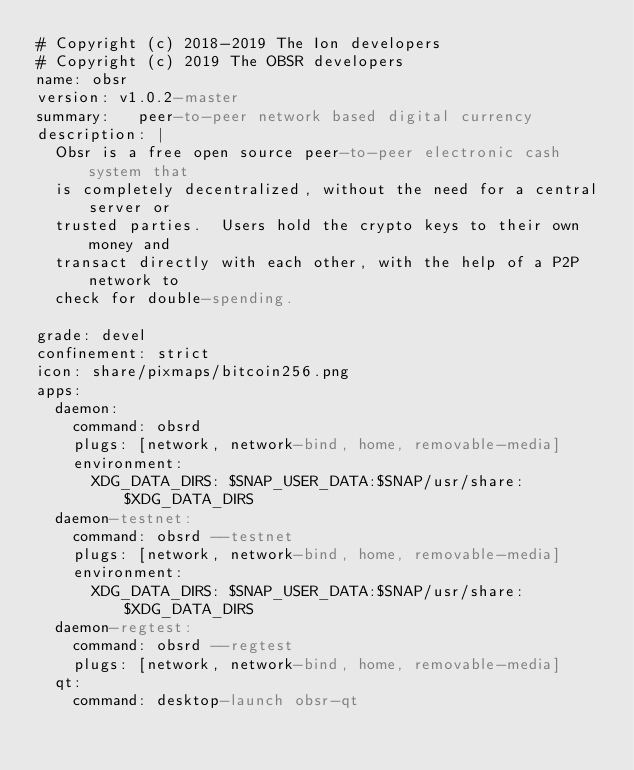<code> <loc_0><loc_0><loc_500><loc_500><_YAML_># Copyright (c) 2018-2019 The Ion developers
# Copyright (c) 2019 The OBSR developers
name: obsr
version: v1.0.2-master
summary:   peer-to-peer network based digital currency
description: |
  Obsr is a free open source peer-to-peer electronic cash system that
  is completely decentralized, without the need for a central server or
  trusted parties.  Users hold the crypto keys to their own money and
  transact directly with each other, with the help of a P2P network to
  check for double-spending.

grade: devel
confinement: strict
icon: share/pixmaps/bitcoin256.png
apps:
  daemon:
    command: obsrd
    plugs: [network, network-bind, home, removable-media]
    environment:
      XDG_DATA_DIRS: $SNAP_USER_DATA:$SNAP/usr/share:$XDG_DATA_DIRS
  daemon-testnet:
    command: obsrd --testnet
    plugs: [network, network-bind, home, removable-media]
    environment:
      XDG_DATA_DIRS: $SNAP_USER_DATA:$SNAP/usr/share:$XDG_DATA_DIRS
  daemon-regtest:
    command: obsrd --regtest
    plugs: [network, network-bind, home, removable-media]
  qt:
    command: desktop-launch obsr-qt</code> 